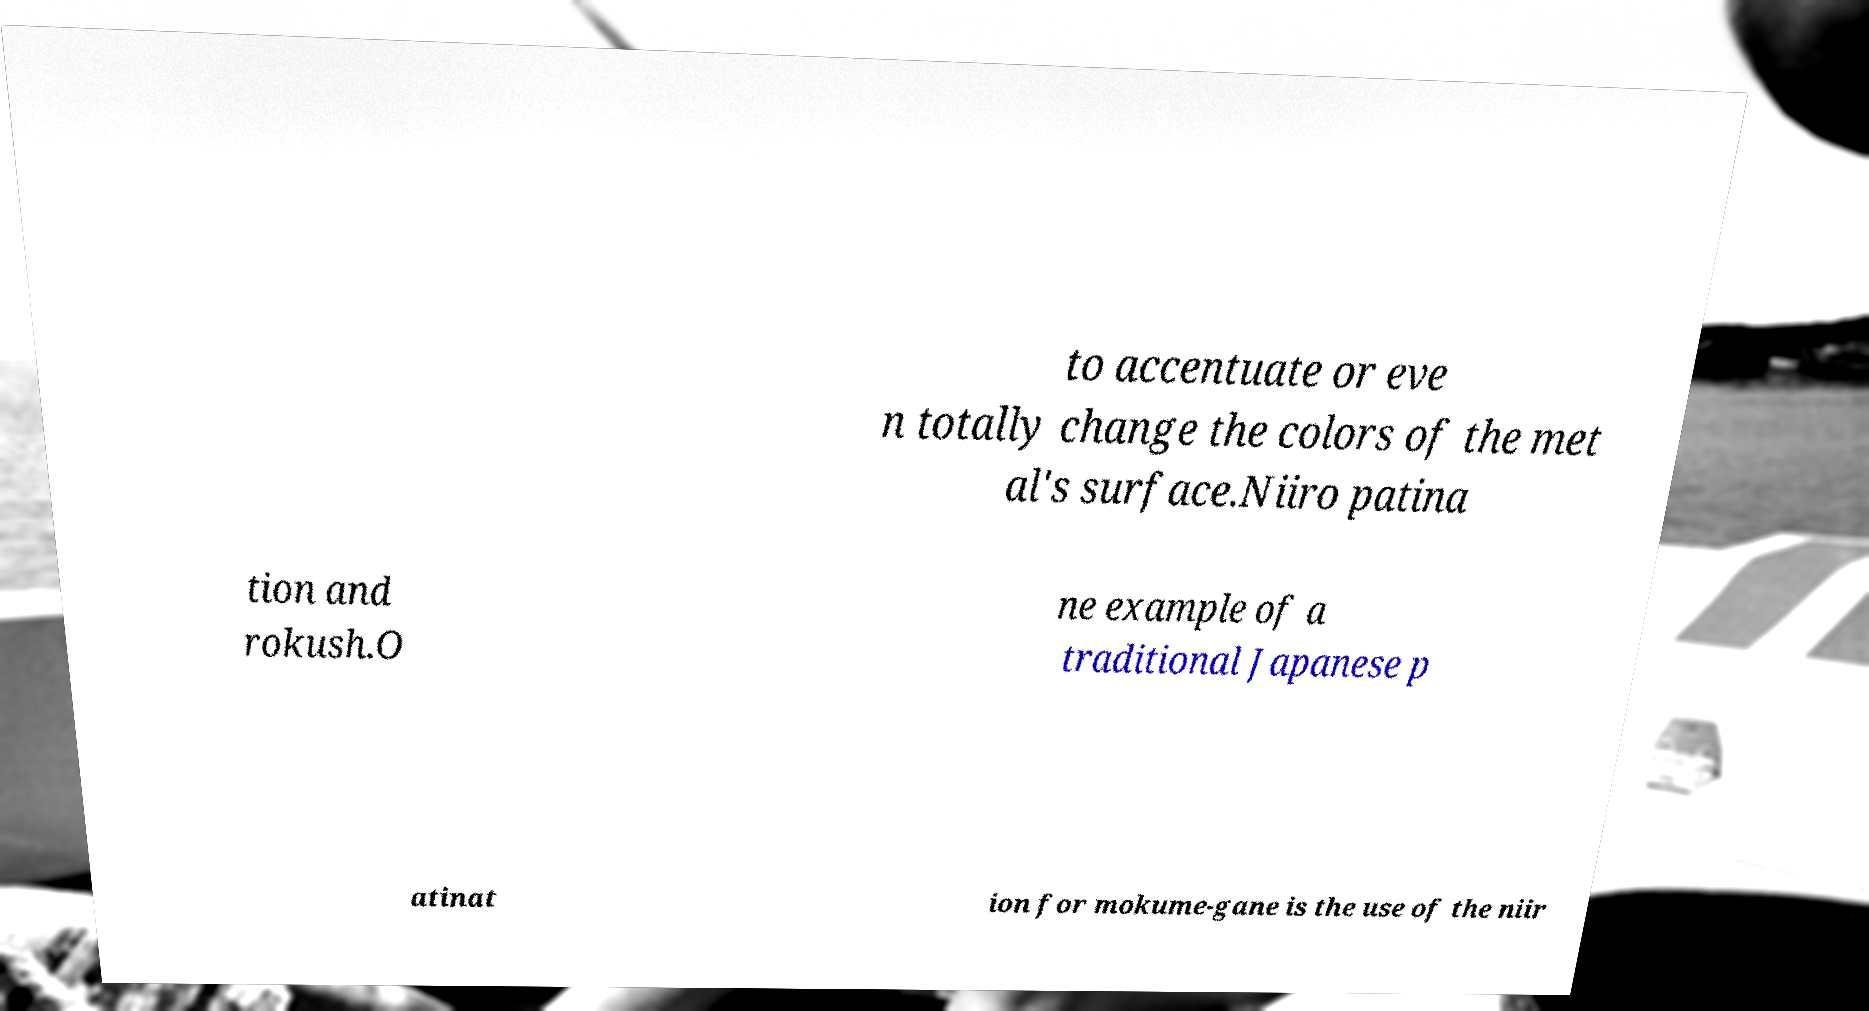Could you extract and type out the text from this image? to accentuate or eve n totally change the colors of the met al's surface.Niiro patina tion and rokush.O ne example of a traditional Japanese p atinat ion for mokume-gane is the use of the niir 